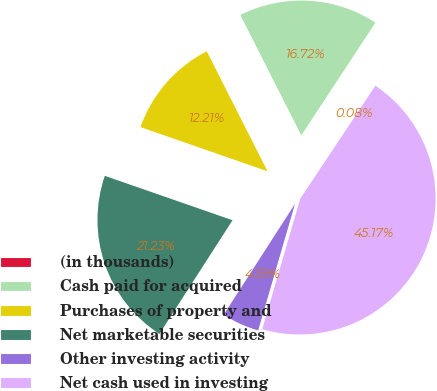<chart> <loc_0><loc_0><loc_500><loc_500><pie_chart><fcel>(in thousands)<fcel>Cash paid for acquired<fcel>Purchases of property and<fcel>Net marketable securities<fcel>Other investing activity<fcel>Net cash used in investing<nl><fcel>0.08%<fcel>16.72%<fcel>12.21%<fcel>21.23%<fcel>4.59%<fcel>45.17%<nl></chart> 